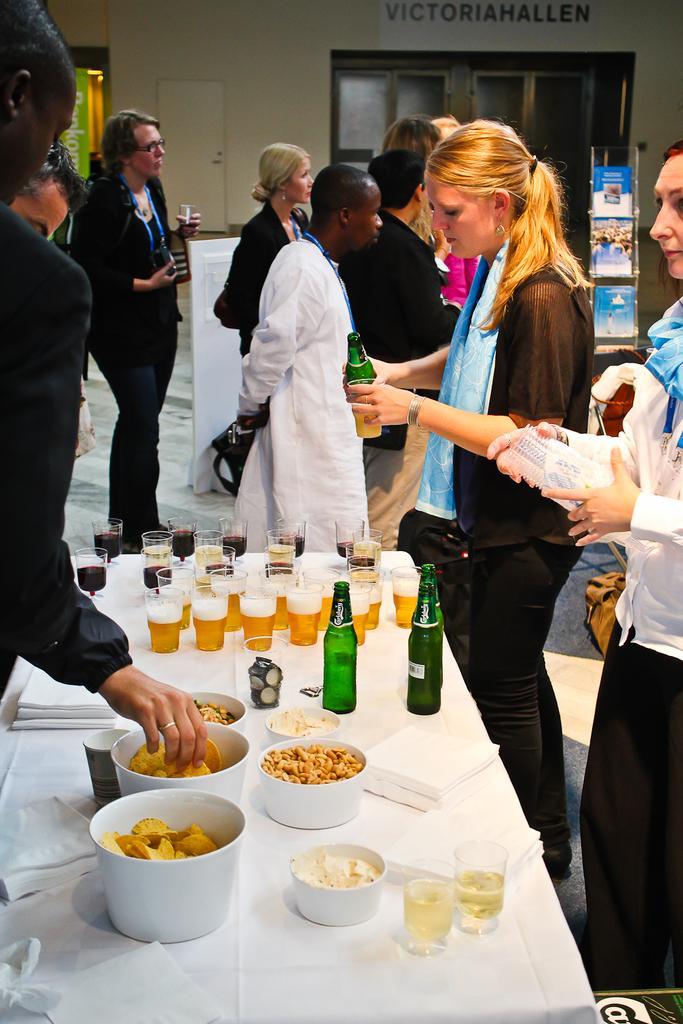In one or two sentences, can you explain what this image depicts? In this image I can see the group people and few people are holding something. I can see few glasses, food items, bottles and few objects on the white color table. I can see the book-rack, wall, glass doors and few objects. 